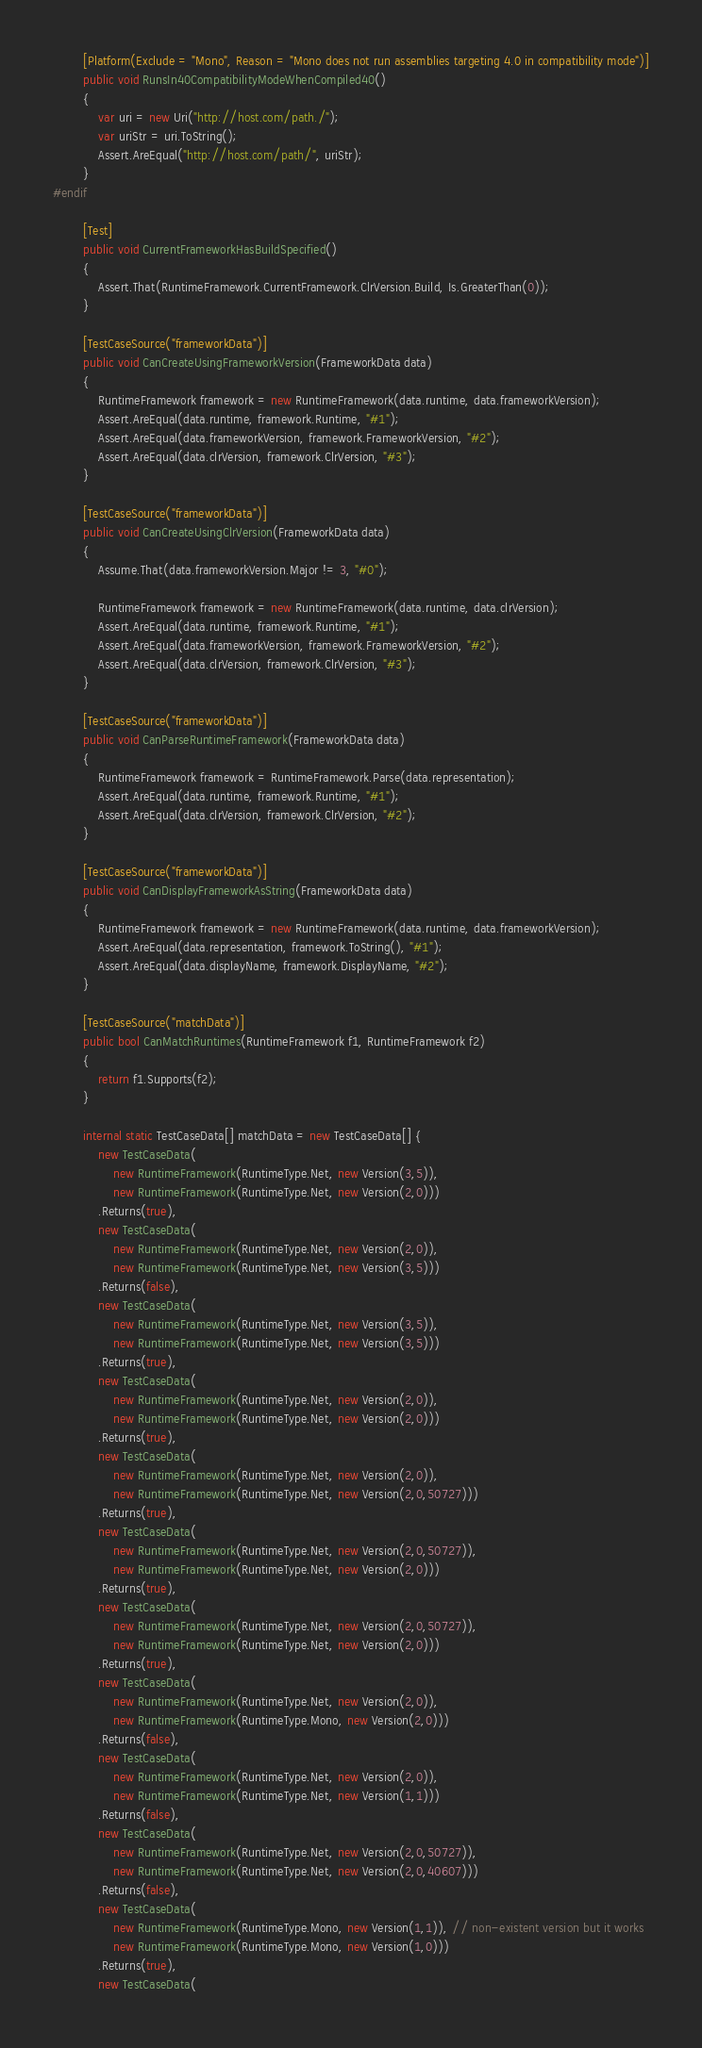<code> <loc_0><loc_0><loc_500><loc_500><_C#_>        [Platform(Exclude = "Mono", Reason = "Mono does not run assemblies targeting 4.0 in compatibility mode")]
        public void RunsIn40CompatibilityModeWhenCompiled40()
        {
            var uri = new Uri("http://host.com/path./");
            var uriStr = uri.ToString();
            Assert.AreEqual("http://host.com/path/", uriStr);
        }
#endif

        [Test]
        public void CurrentFrameworkHasBuildSpecified()
        {
            Assert.That(RuntimeFramework.CurrentFramework.ClrVersion.Build, Is.GreaterThan(0));
        }

        [TestCaseSource("frameworkData")]
        public void CanCreateUsingFrameworkVersion(FrameworkData data)
        {
            RuntimeFramework framework = new RuntimeFramework(data.runtime, data.frameworkVersion);
            Assert.AreEqual(data.runtime, framework.Runtime, "#1");
            Assert.AreEqual(data.frameworkVersion, framework.FrameworkVersion, "#2");
            Assert.AreEqual(data.clrVersion, framework.ClrVersion, "#3");
        }

        [TestCaseSource("frameworkData")]
        public void CanCreateUsingClrVersion(FrameworkData data)
        {
            Assume.That(data.frameworkVersion.Major != 3, "#0");

            RuntimeFramework framework = new RuntimeFramework(data.runtime, data.clrVersion);
            Assert.AreEqual(data.runtime, framework.Runtime, "#1");
            Assert.AreEqual(data.frameworkVersion, framework.FrameworkVersion, "#2");
            Assert.AreEqual(data.clrVersion, framework.ClrVersion, "#3");
        }

        [TestCaseSource("frameworkData")]
        public void CanParseRuntimeFramework(FrameworkData data)
        {
            RuntimeFramework framework = RuntimeFramework.Parse(data.representation);
            Assert.AreEqual(data.runtime, framework.Runtime, "#1");
            Assert.AreEqual(data.clrVersion, framework.ClrVersion, "#2");
        }

        [TestCaseSource("frameworkData")]
        public void CanDisplayFrameworkAsString(FrameworkData data)
        {
            RuntimeFramework framework = new RuntimeFramework(data.runtime, data.frameworkVersion);
            Assert.AreEqual(data.representation, framework.ToString(), "#1");
            Assert.AreEqual(data.displayName, framework.DisplayName, "#2");
        }

        [TestCaseSource("matchData")]
        public bool CanMatchRuntimes(RuntimeFramework f1, RuntimeFramework f2)
        {
            return f1.Supports(f2);
        }

        internal static TestCaseData[] matchData = new TestCaseData[] {
            new TestCaseData(
                new RuntimeFramework(RuntimeType.Net, new Version(3,5)),
                new RuntimeFramework(RuntimeType.Net, new Version(2,0)))
            .Returns(true),
            new TestCaseData(
                new RuntimeFramework(RuntimeType.Net, new Version(2,0)),
                new RuntimeFramework(RuntimeType.Net, new Version(3,5)))
            .Returns(false),
            new TestCaseData(
                new RuntimeFramework(RuntimeType.Net, new Version(3,5)),
                new RuntimeFramework(RuntimeType.Net, new Version(3,5)))
            .Returns(true),
            new TestCaseData(
                new RuntimeFramework(RuntimeType.Net, new Version(2,0)),
                new RuntimeFramework(RuntimeType.Net, new Version(2,0)))
            .Returns(true),
            new TestCaseData(
                new RuntimeFramework(RuntimeType.Net, new Version(2,0)),
                new RuntimeFramework(RuntimeType.Net, new Version(2,0,50727)))
            .Returns(true),
            new TestCaseData(
                new RuntimeFramework(RuntimeType.Net, new Version(2,0,50727)),
                new RuntimeFramework(RuntimeType.Net, new Version(2,0)))
            .Returns(true),
            new TestCaseData(
                new RuntimeFramework(RuntimeType.Net, new Version(2,0,50727)),
                new RuntimeFramework(RuntimeType.Net, new Version(2,0)))
            .Returns(true),
            new TestCaseData(
                new RuntimeFramework(RuntimeType.Net, new Version(2,0)),
                new RuntimeFramework(RuntimeType.Mono, new Version(2,0)))
            .Returns(false),
            new TestCaseData(
                new RuntimeFramework(RuntimeType.Net, new Version(2,0)),
                new RuntimeFramework(RuntimeType.Net, new Version(1,1)))
            .Returns(false),
            new TestCaseData(
                new RuntimeFramework(RuntimeType.Net, new Version(2,0,50727)),
                new RuntimeFramework(RuntimeType.Net, new Version(2,0,40607)))
            .Returns(false),
            new TestCaseData(
                new RuntimeFramework(RuntimeType.Mono, new Version(1,1)), // non-existent version but it works
                new RuntimeFramework(RuntimeType.Mono, new Version(1,0)))
            .Returns(true),
            new TestCaseData(</code> 